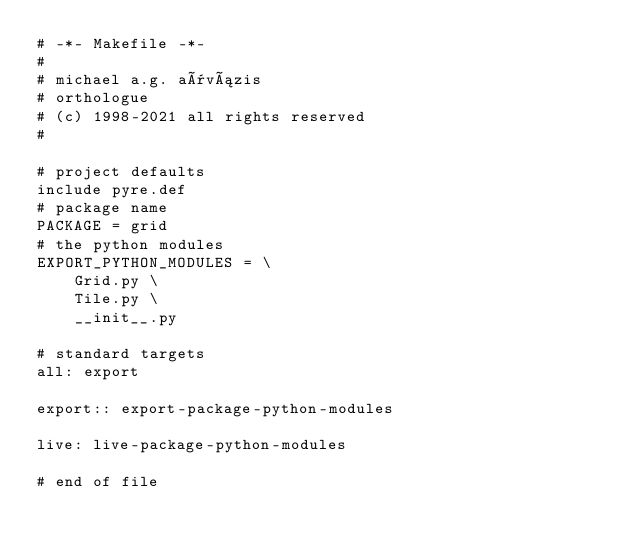<code> <loc_0><loc_0><loc_500><loc_500><_ObjectiveC_># -*- Makefile -*-
#
# michael a.g. aïvázis
# orthologue
# (c) 1998-2021 all rights reserved
#

# project defaults
include pyre.def
# package name
PACKAGE = grid
# the python modules
EXPORT_PYTHON_MODULES = \
    Grid.py \
    Tile.py \
    __init__.py

# standard targets
all: export

export:: export-package-python-modules

live: live-package-python-modules

# end of file
</code> 